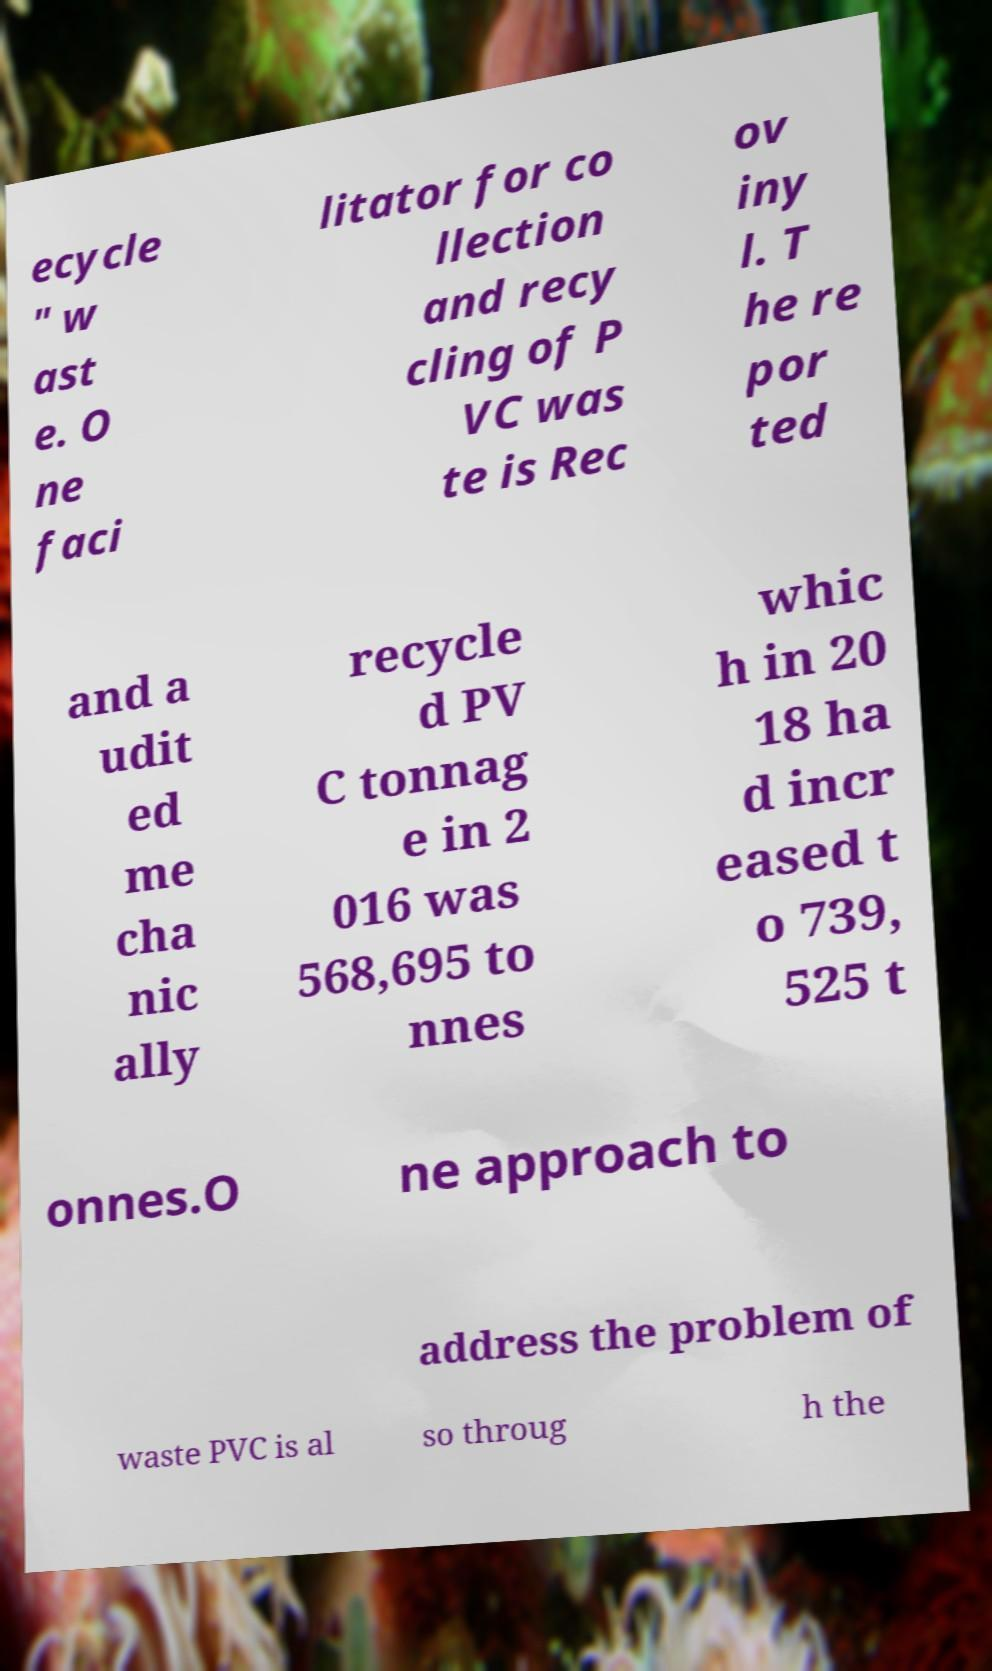Can you accurately transcribe the text from the provided image for me? ecycle " w ast e. O ne faci litator for co llection and recy cling of P VC was te is Rec ov iny l. T he re por ted and a udit ed me cha nic ally recycle d PV C tonnag e in 2 016 was 568,695 to nnes whic h in 20 18 ha d incr eased t o 739, 525 t onnes.O ne approach to address the problem of waste PVC is al so throug h the 